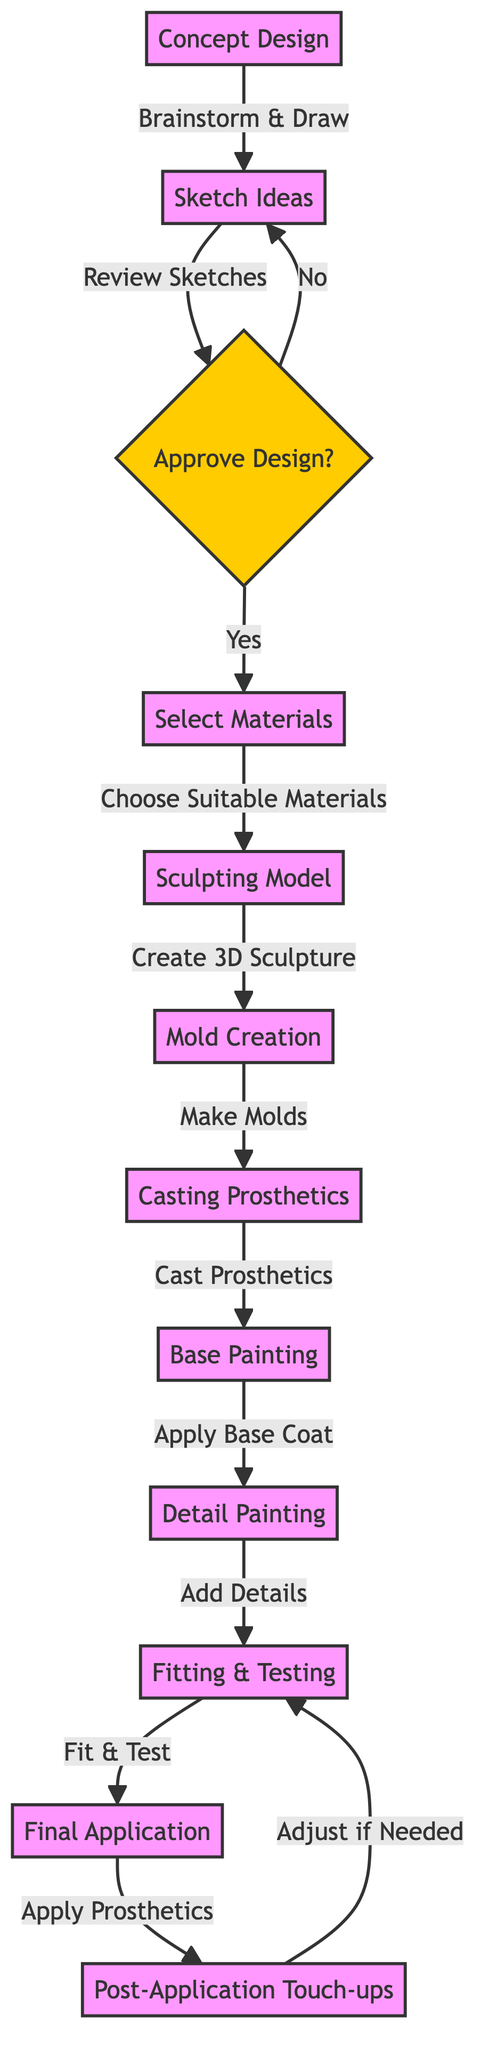What is the first step in the special effects makeup process? The first step, as shown in the diagram, is "Concept Design," which initiates the entire process.
Answer: Concept Design How many decision points are present in the diagram? By reviewing the diagram, we can identify one decision point at "Approve Design," making it the sole decision point.
Answer: 1 What happens after "Sketch Ideas" if the design is not approved? According to the flowchart, if the design is not approved, the next step directs back to "Sketch Ideas" for reworking.
Answer: Sketch Ideas What is the label of the node after "Casting Prosthetics"? The flowchart indicates that the node following "Casting Prosthetics" is "Base Painting," representing the next step in the process.
Answer: Base Painting What action is taken after "Detailed Painting"? The diagram specifies that "Fitting & Testing" follows "Detailed Painting," indicating this action comes next in the flow.
Answer: Fitting & Testing What is the relationship between "Post-Application Touch-ups" and "Fitting & Testing"? The flowchart shows a circular relationship where "Post-Application Touch-ups" leads back to "Fitting & Testing," indicating an iterative process for adjustments.
Answer: Iterative Loop What material selection technique is specified in the diagram? The diagram describes the action taken during the material selection phase as "Choose Suitable Materials," indicating the type of decision made.
Answer: Choose Suitable Materials How many total steps are in the makeup application process? Counting each node from "Concept Design" to "Post-Application Touch-ups," we find there are a total of 10 distinct steps listed in the process.
Answer: 10 What action follows "Final Application" in the flowchart? The diagram establishes that "Post-Application Touch-ups" is the step following "Final Application," indicating a subsequent review process.
Answer: Post-Application Touch-ups 